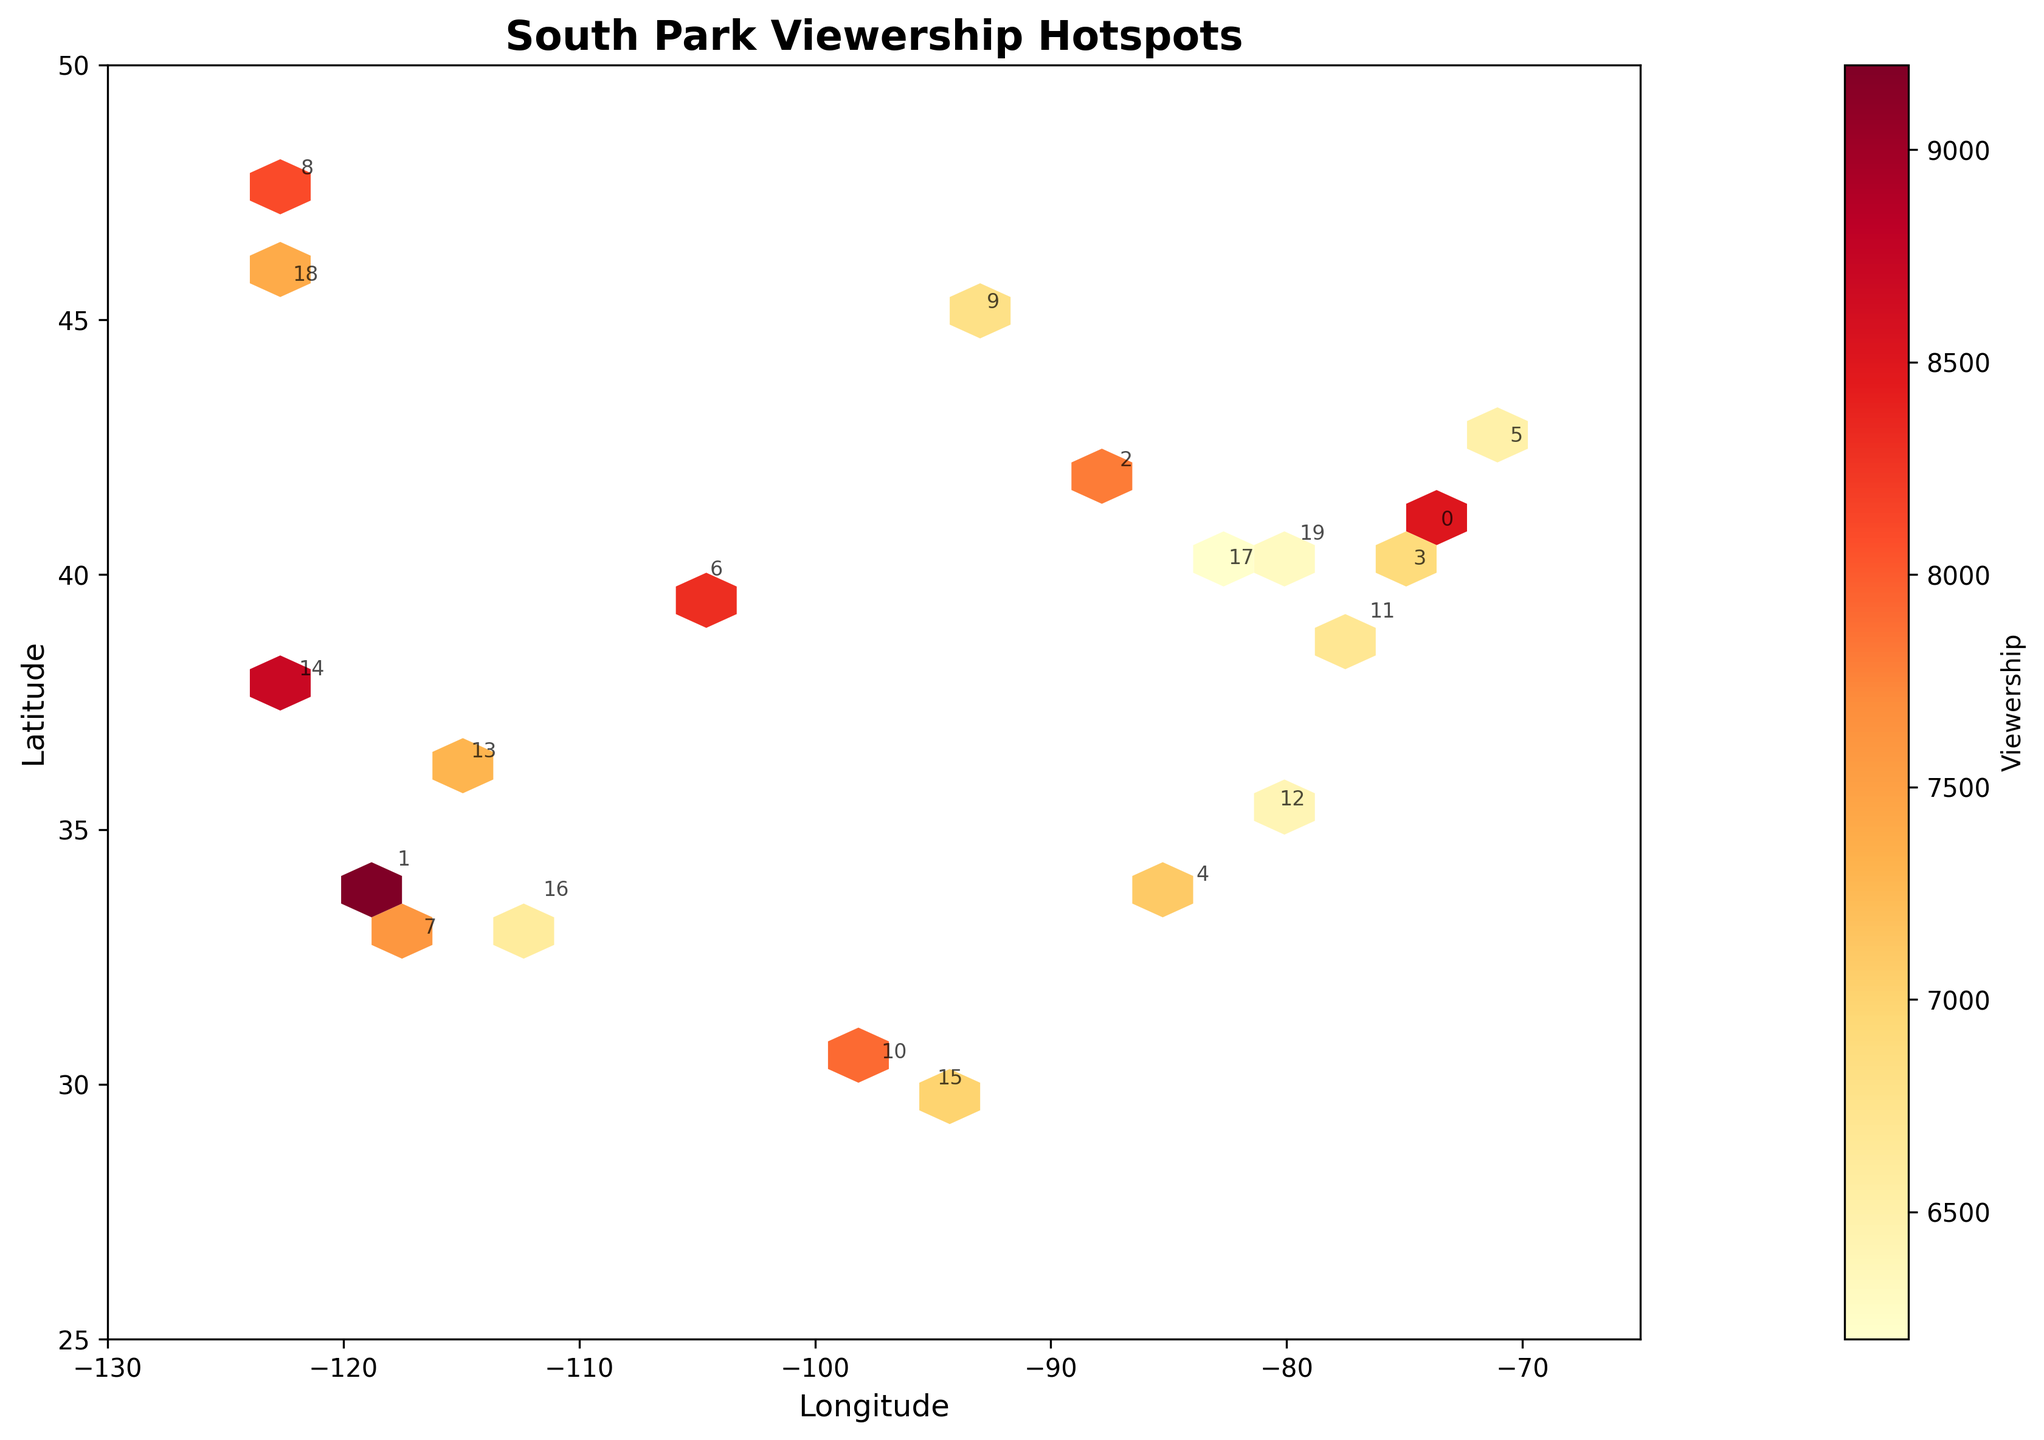What is the title of the hexbin plot? The title is usually displayed at the top of the plot. Here, it reads "South Park Viewership Hotspots".
Answer: South Park Viewership Hotspots What do the colors in the hexagons represent? In a hexbin plot, colors typically denote the intensity of a variable being plotted. Here, the color gradient (YlOrRd) represents varying levels of South Park viewership.
Answer: Viewership intensity Which city has the highest viewership? Look for the hexagon with the most intense color and see which city is annotated nearby. Los Angeles has the highest viewership according to the data provided.
Answer: Los Angeles How does the viewership in Seattle compare to that in Houston? Compare the color intensity of the hexagons representing Seattle and Houston. Seattle's viewership is higher than Houston's given the more intense color representation.
Answer: Seattle has higher viewership Where on the map are most of the viewership hotspots located? Identify the regions with the most densely populated intense colors. The hotspots are concentrated along the East Coast and the West Coast of the U.S.
Answer: East Coast and West Coast Which two cities have nearly the same level of viewership? Compare the color intensities and annotations. Philadelphia and Atlanta have similar color intensities, indicating similar levels of viewership.
Answer: Philadelphia and Atlanta What range of longitudes does the plot cover? Check the x-axis labels for the range of displayed longitudes, which span from -130 to -65.
Answer: -130 to -65 What does the color bar on the right side represent? The color bar’s label indicates that it shows the viewership levels, determining the translation from color intensity to actual viewership numbers.
Answer: Viewership What is the difference in viewership between New York and Denver? Subtract New York's viewership (8500) from Denver's (8300). The difference is 8500 - 8300 = 200 viewers.
Answer: 200 viewers Which city has the lowest viewership, and what is that viewership level? Look for the city with the least intense color nearest to its annotation. Columbus has the lowest viewership based on the provided data, with around 6200 viewers.
Answer: Columbus with 6200 viewers 